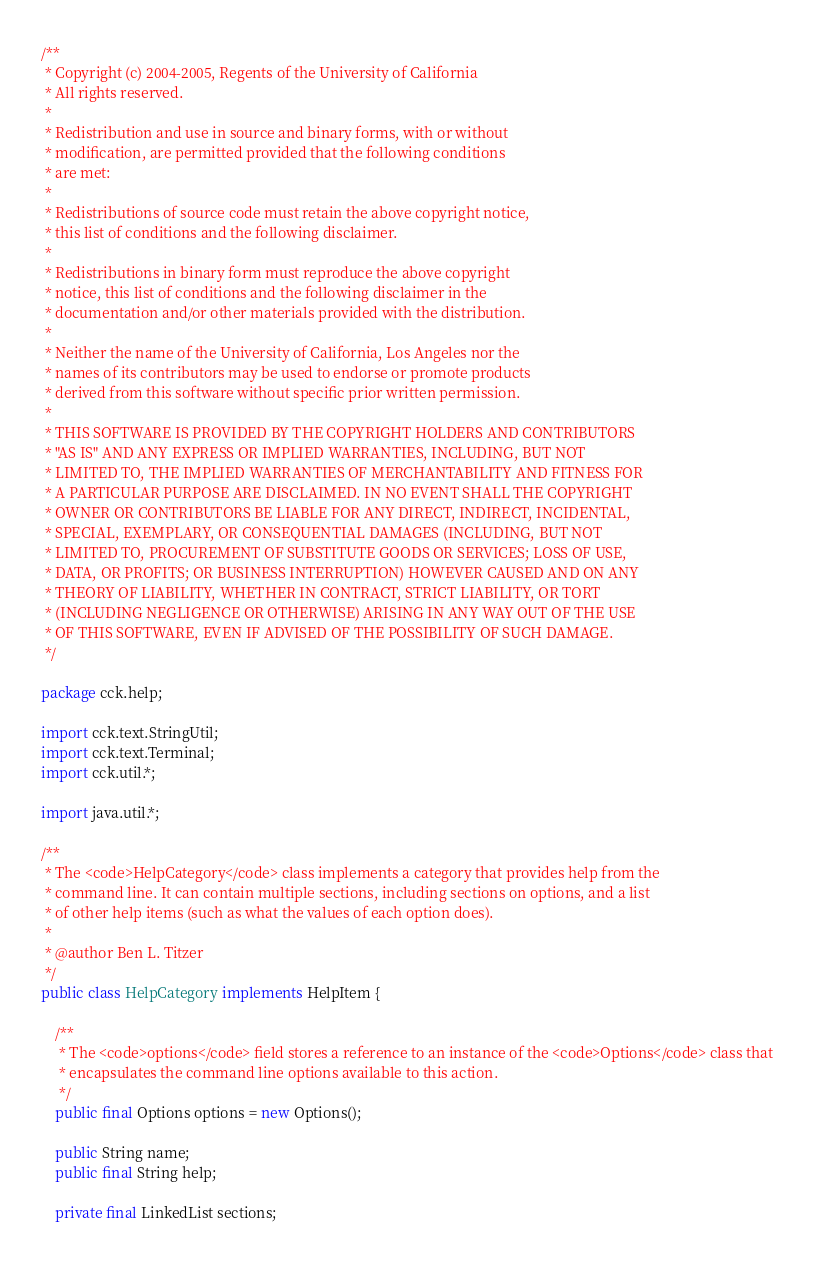Convert code to text. <code><loc_0><loc_0><loc_500><loc_500><_Java_>/**
 * Copyright (c) 2004-2005, Regents of the University of California
 * All rights reserved.
 *
 * Redistribution and use in source and binary forms, with or without
 * modification, are permitted provided that the following conditions
 * are met:
 *
 * Redistributions of source code must retain the above copyright notice,
 * this list of conditions and the following disclaimer.
 *
 * Redistributions in binary form must reproduce the above copyright
 * notice, this list of conditions and the following disclaimer in the
 * documentation and/or other materials provided with the distribution.
 *
 * Neither the name of the University of California, Los Angeles nor the
 * names of its contributors may be used to endorse or promote products
 * derived from this software without specific prior written permission.
 *
 * THIS SOFTWARE IS PROVIDED BY THE COPYRIGHT HOLDERS AND CONTRIBUTORS
 * "AS IS" AND ANY EXPRESS OR IMPLIED WARRANTIES, INCLUDING, BUT NOT
 * LIMITED TO, THE IMPLIED WARRANTIES OF MERCHANTABILITY AND FITNESS FOR
 * A PARTICULAR PURPOSE ARE DISCLAIMED. IN NO EVENT SHALL THE COPYRIGHT
 * OWNER OR CONTRIBUTORS BE LIABLE FOR ANY DIRECT, INDIRECT, INCIDENTAL,
 * SPECIAL, EXEMPLARY, OR CONSEQUENTIAL DAMAGES (INCLUDING, BUT NOT
 * LIMITED TO, PROCUREMENT OF SUBSTITUTE GOODS OR SERVICES; LOSS OF USE,
 * DATA, OR PROFITS; OR BUSINESS INTERRUPTION) HOWEVER CAUSED AND ON ANY
 * THEORY OF LIABILITY, WHETHER IN CONTRACT, STRICT LIABILITY, OR TORT
 * (INCLUDING NEGLIGENCE OR OTHERWISE) ARISING IN ANY WAY OUT OF THE USE
 * OF THIS SOFTWARE, EVEN IF ADVISED OF THE POSSIBILITY OF SUCH DAMAGE.
 */

package cck.help;

import cck.text.StringUtil;
import cck.text.Terminal;
import cck.util.*;

import java.util.*;

/**
 * The <code>HelpCategory</code> class implements a category that provides help from the
 * command line. It can contain multiple sections, including sections on options, and a list
 * of other help items (such as what the values of each option does).
 *
 * @author Ben L. Titzer
 */
public class HelpCategory implements HelpItem {

    /**
     * The <code>options</code> field stores a reference to an instance of the <code>Options</code> class that
     * encapsulates the command line options available to this action.
     */
    public final Options options = new Options();

    public String name;
    public final String help;

    private final LinkedList sections;
</code> 